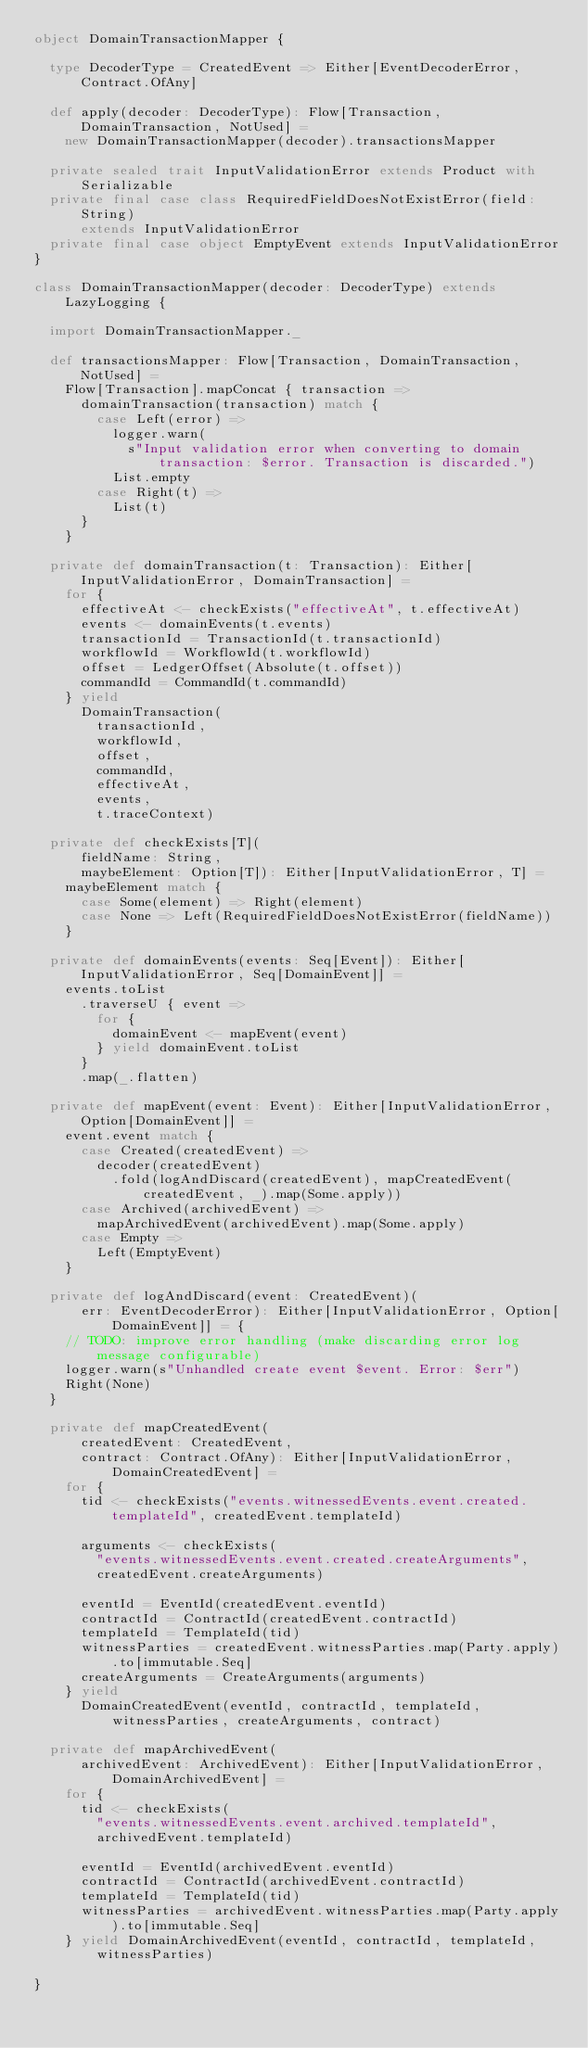<code> <loc_0><loc_0><loc_500><loc_500><_Scala_>object DomainTransactionMapper {

  type DecoderType = CreatedEvent => Either[EventDecoderError, Contract.OfAny]

  def apply(decoder: DecoderType): Flow[Transaction, DomainTransaction, NotUsed] =
    new DomainTransactionMapper(decoder).transactionsMapper

  private sealed trait InputValidationError extends Product with Serializable
  private final case class RequiredFieldDoesNotExistError(field: String)
      extends InputValidationError
  private final case object EmptyEvent extends InputValidationError
}

class DomainTransactionMapper(decoder: DecoderType) extends LazyLogging {

  import DomainTransactionMapper._

  def transactionsMapper: Flow[Transaction, DomainTransaction, NotUsed] =
    Flow[Transaction].mapConcat { transaction =>
      domainTransaction(transaction) match {
        case Left(error) =>
          logger.warn(
            s"Input validation error when converting to domain transaction: $error. Transaction is discarded.")
          List.empty
        case Right(t) =>
          List(t)
      }
    }

  private def domainTransaction(t: Transaction): Either[InputValidationError, DomainTransaction] =
    for {
      effectiveAt <- checkExists("effectiveAt", t.effectiveAt)
      events <- domainEvents(t.events)
      transactionId = TransactionId(t.transactionId)
      workflowId = WorkflowId(t.workflowId)
      offset = LedgerOffset(Absolute(t.offset))
      commandId = CommandId(t.commandId)
    } yield
      DomainTransaction(
        transactionId,
        workflowId,
        offset,
        commandId,
        effectiveAt,
        events,
        t.traceContext)

  private def checkExists[T](
      fieldName: String,
      maybeElement: Option[T]): Either[InputValidationError, T] =
    maybeElement match {
      case Some(element) => Right(element)
      case None => Left(RequiredFieldDoesNotExistError(fieldName))
    }

  private def domainEvents(events: Seq[Event]): Either[InputValidationError, Seq[DomainEvent]] =
    events.toList
      .traverseU { event =>
        for {
          domainEvent <- mapEvent(event)
        } yield domainEvent.toList
      }
      .map(_.flatten)

  private def mapEvent(event: Event): Either[InputValidationError, Option[DomainEvent]] =
    event.event match {
      case Created(createdEvent) =>
        decoder(createdEvent)
          .fold(logAndDiscard(createdEvent), mapCreatedEvent(createdEvent, _).map(Some.apply))
      case Archived(archivedEvent) =>
        mapArchivedEvent(archivedEvent).map(Some.apply)
      case Empty =>
        Left(EmptyEvent)
    }

  private def logAndDiscard(event: CreatedEvent)(
      err: EventDecoderError): Either[InputValidationError, Option[DomainEvent]] = {
    // TODO: improve error handling (make discarding error log message configurable)
    logger.warn(s"Unhandled create event $event. Error: $err")
    Right(None)
  }

  private def mapCreatedEvent(
      createdEvent: CreatedEvent,
      contract: Contract.OfAny): Either[InputValidationError, DomainCreatedEvent] =
    for {
      tid <- checkExists("events.witnessedEvents.event.created.templateId", createdEvent.templateId)

      arguments <- checkExists(
        "events.witnessedEvents.event.created.createArguments",
        createdEvent.createArguments)

      eventId = EventId(createdEvent.eventId)
      contractId = ContractId(createdEvent.contractId)
      templateId = TemplateId(tid)
      witnessParties = createdEvent.witnessParties.map(Party.apply).to[immutable.Seq]
      createArguments = CreateArguments(arguments)
    } yield
      DomainCreatedEvent(eventId, contractId, templateId, witnessParties, createArguments, contract)

  private def mapArchivedEvent(
      archivedEvent: ArchivedEvent): Either[InputValidationError, DomainArchivedEvent] =
    for {
      tid <- checkExists(
        "events.witnessedEvents.event.archived.templateId",
        archivedEvent.templateId)

      eventId = EventId(archivedEvent.eventId)
      contractId = ContractId(archivedEvent.contractId)
      templateId = TemplateId(tid)
      witnessParties = archivedEvent.witnessParties.map(Party.apply).to[immutable.Seq]
    } yield DomainArchivedEvent(eventId, contractId, templateId, witnessParties)

}
</code> 